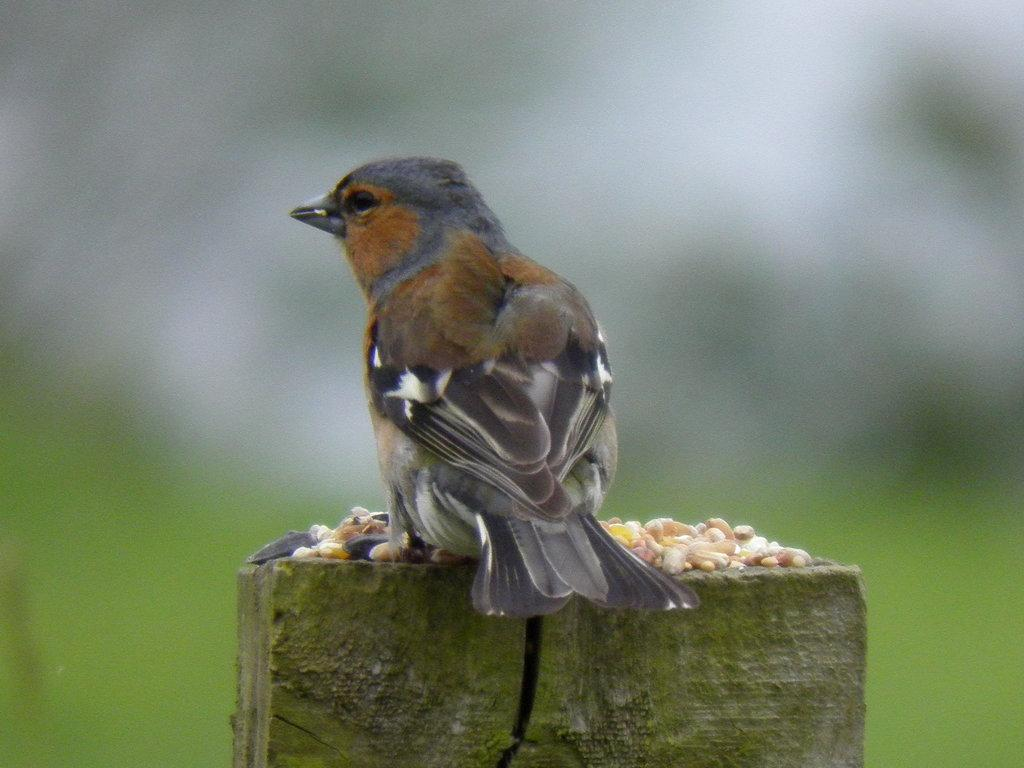What type of animal can be seen in the image? There is a bird in the image. Can you describe the background of the image? The background of the image is blurred. What list of items can be seen in the image? There is no list of items present in the image; it features a bird and a blurred background. How many children are visible in the image? There are no children visible in the image; it features a bird and a blurred background. 